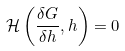<formula> <loc_0><loc_0><loc_500><loc_500>\mathcal { H } \left ( \frac { \delta G } { \delta h } , h \right ) = 0</formula> 